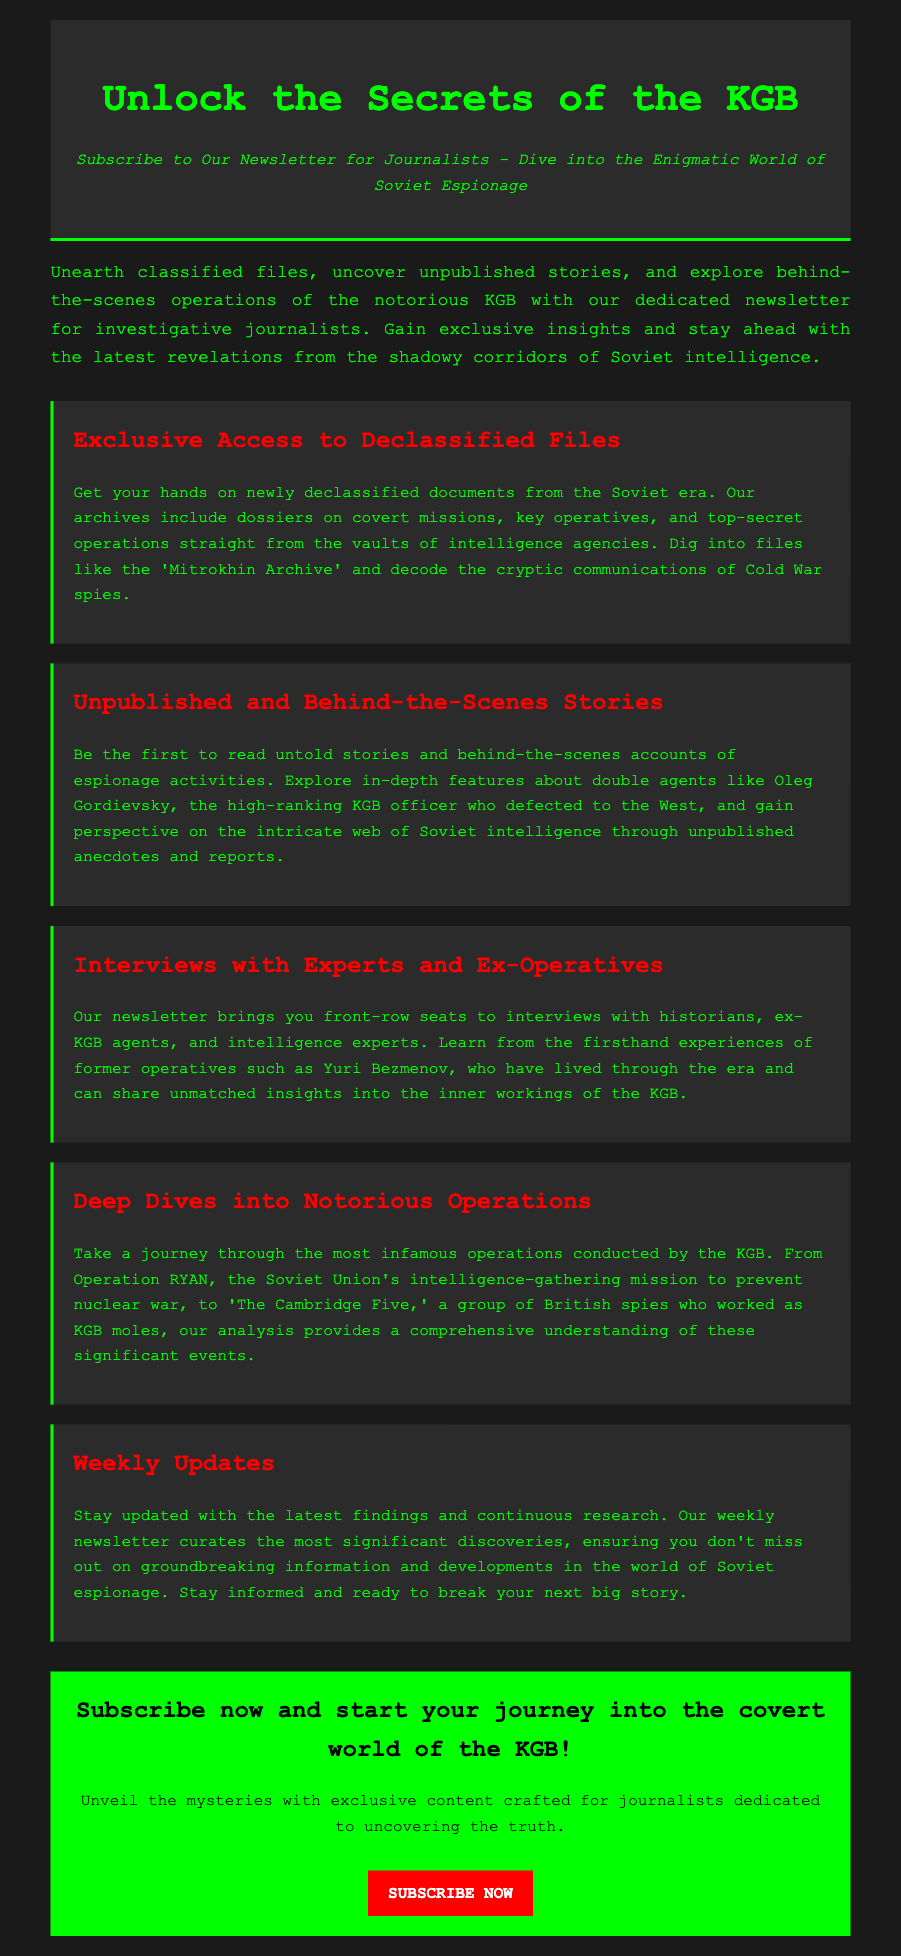What is the title of the newsletter? The title of the newsletter is presented prominently at the top of the document.
Answer: Unlock the Secrets of the KGB What type of access does the newsletter provide? The document specifies that subscribers will gain access to certain types of information.
Answer: Exclusive Access to Declassified Files Who is mentioned as a key figure in unpublished stories? The unread stories section includes references to significant historical figures in espionage.
Answer: Oleg Gordievsky What type of individuals are featured in interviews? The document indicates that the newsletter includes interviews with professionals related to the KGB.
Answer: Historians, ex-KGB agents, and intelligence experts How often are updates provided in the newsletter? The document specifies the frequency of updates you will receive as a subscriber.
Answer: Weekly Updates What color is used for the call-to-action button? The color of the call-to-action button is essential for attracting attention in the advertisement.
Answer: Red What type of missions are explored in the deep dives section? The deep dives section describes particular categories of operations associated with the KGB.
Answer: Notorious Operations What is the target audience for the newsletter? The overall content indicates who would benefit most from subscribing to the newsletter.
Answer: Journalists 